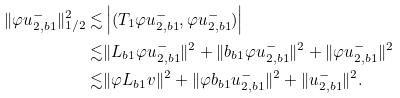Convert formula to latex. <formula><loc_0><loc_0><loc_500><loc_500>\| \varphi u _ { 2 , b 1 } ^ { - } \| _ { 1 / 2 } ^ { 2 } \lesssim & \left | ( T _ { 1 } \varphi u _ { 2 , b 1 } ^ { - } , \varphi u _ { 2 , b 1 } ^ { - } ) \right | \\ \lesssim & \| L _ { b 1 } \varphi u _ { 2 , b 1 } ^ { - } \| ^ { 2 } + \| \L b _ { b 1 } \varphi u _ { 2 , b 1 } ^ { - } \| ^ { 2 } + \| \varphi u _ { 2 , b 1 } ^ { - } \| ^ { 2 } \\ \lesssim & \| \varphi L _ { b 1 } v \| ^ { 2 } + \| \varphi \L b _ { b 1 } u _ { 2 , b 1 } ^ { - } \| ^ { 2 } + \| u _ { 2 , b 1 } ^ { - } \| ^ { 2 } .</formula> 